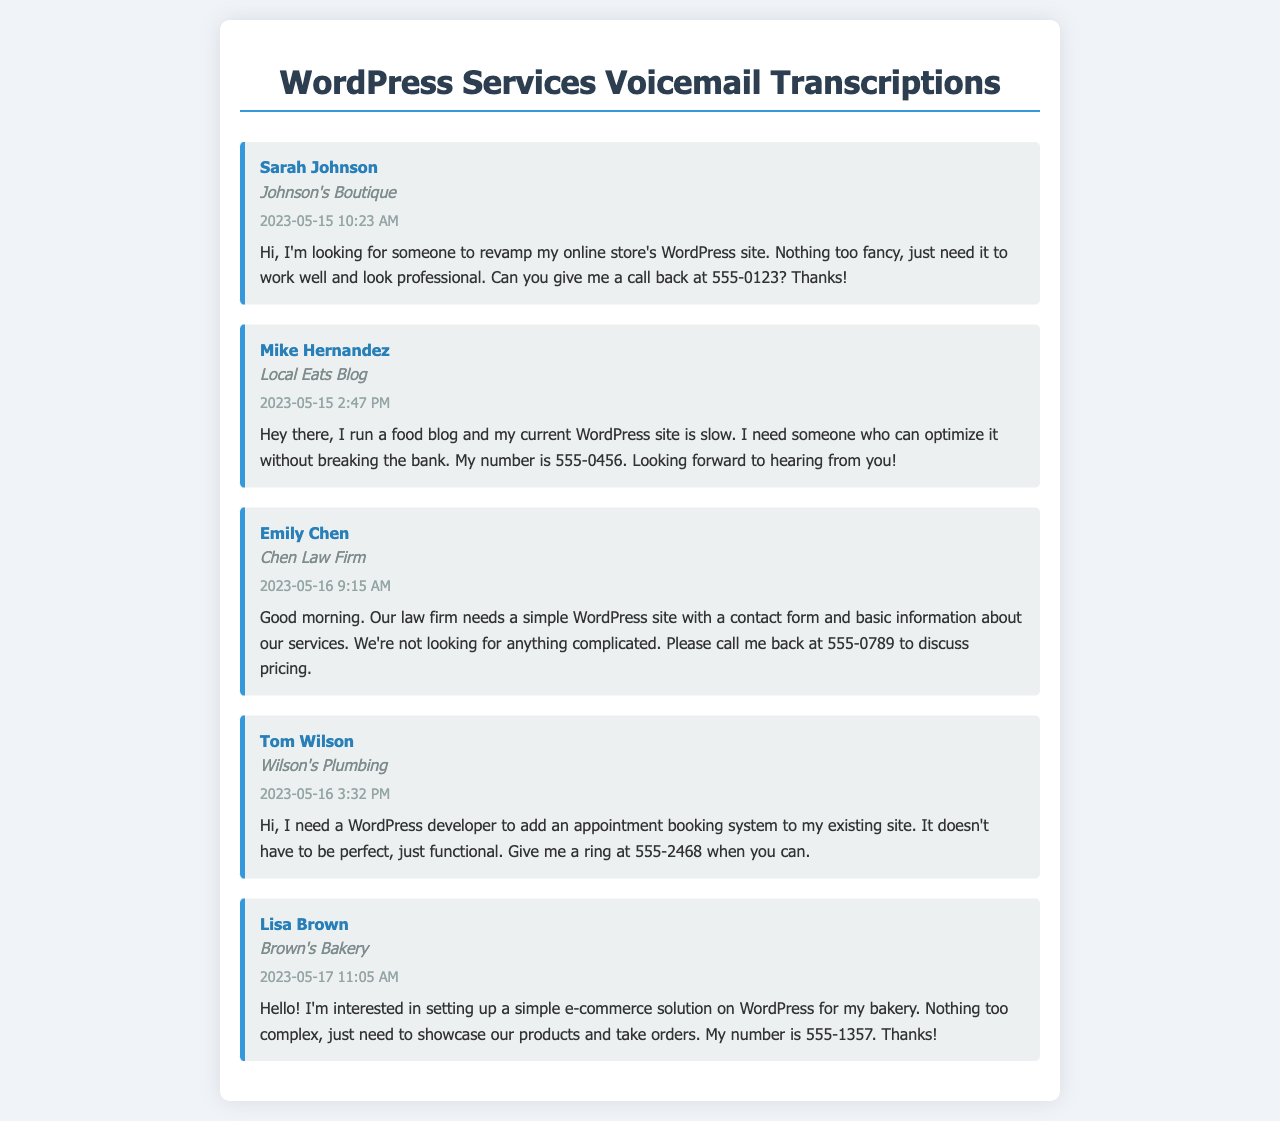What is Sarah Johnson's company name? The company name is provided alongside Sarah Johnson's details in the document.
Answer: Johnson's Boutique What service does Mike Hernandez need? The message from Mike Hernandez states he needs to optimize his WordPress site.
Answer: Optimize my WordPress site What was the timestamp of Emily Chen's voicemail? The timestamp for Emily Chen's message indicates when it was recorded.
Answer: 2023-05-16 9:15 AM What phone number does Tom Wilson provide? Tom Wilson includes his contact number in his message.
Answer: 555-2468 Which service does Lisa Brown want for her bakery? Lisa Brown's message specifies what type of WordPress solution she is interested in.
Answer: E-commerce solution How many clients mention a need for simplicity in their requests? The messages reflect a common theme of clients wanting straightforward solutions.
Answer: Four clients What is a recurring theme in the voicemails received? The messages consistently express a desire for functional but non-complex solutions.
Answer: Non-complex solutions What information is commonly included in the voicemail records? Each voicemail record summarizes the caller's details, timestamp, and request message.
Answer: Caller details, timestamp, request message Which client requested a contact form on their website? Emily Chen explicitly mentions needing a contact form for her law firm.
Answer: Emily Chen 